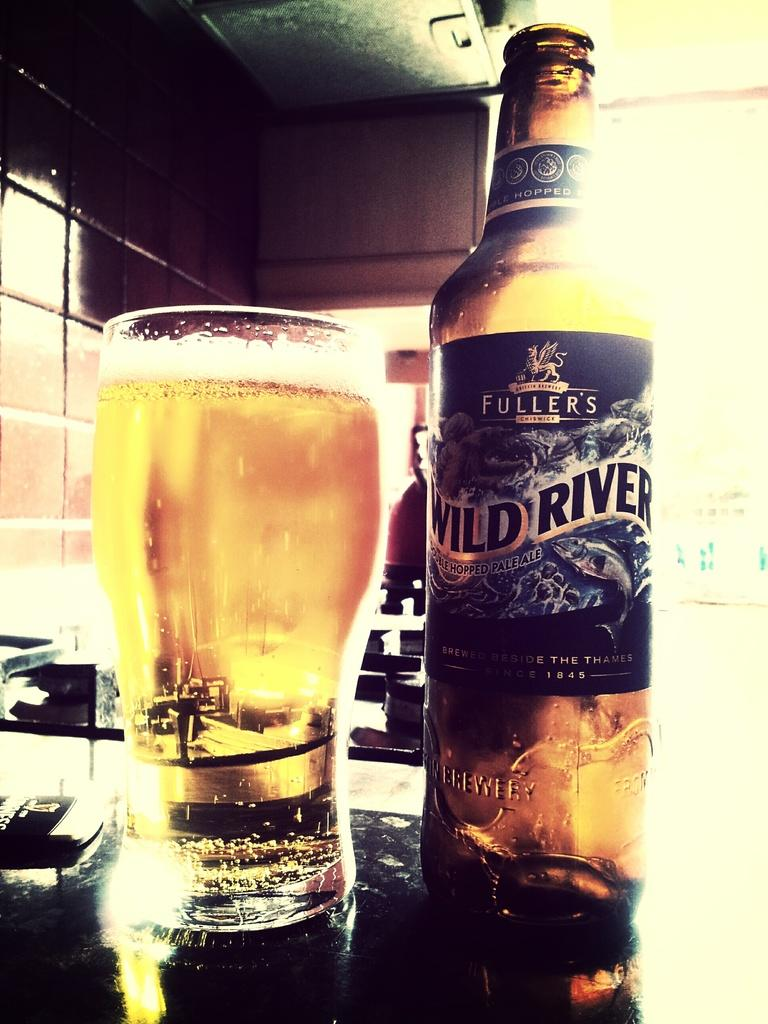Provide a one-sentence caption for the provided image. A glass full of light amber beer next to a bottle that states Fuller's Wild River. 